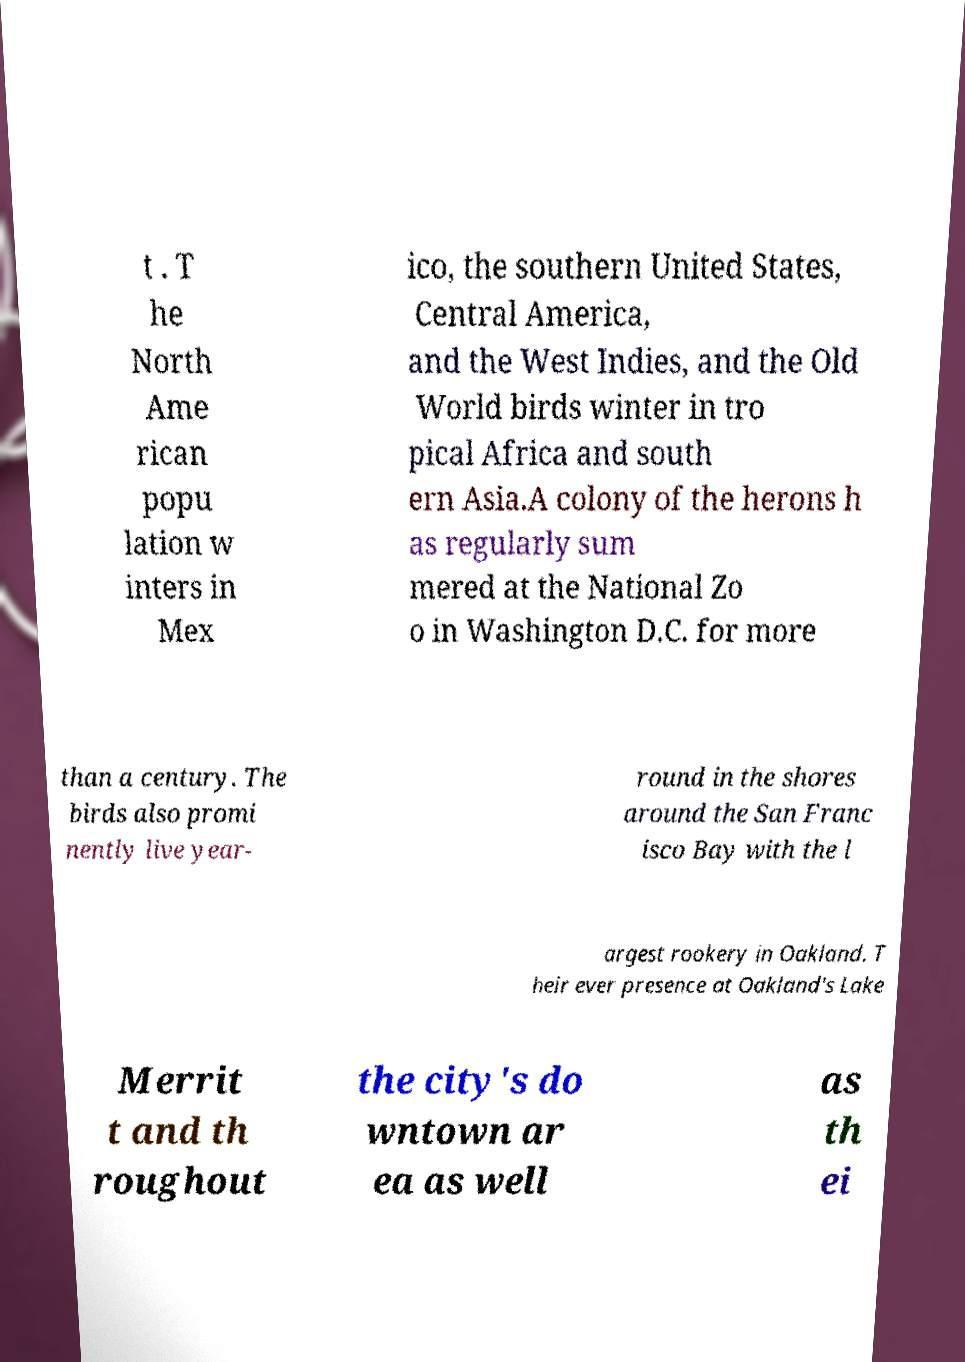Can you accurately transcribe the text from the provided image for me? t . T he North Ame rican popu lation w inters in Mex ico, the southern United States, Central America, and the West Indies, and the Old World birds winter in tro pical Africa and south ern Asia.A colony of the herons h as regularly sum mered at the National Zo o in Washington D.C. for more than a century. The birds also promi nently live year- round in the shores around the San Franc isco Bay with the l argest rookery in Oakland. T heir ever presence at Oakland's Lake Merrit t and th roughout the city's do wntown ar ea as well as th ei 